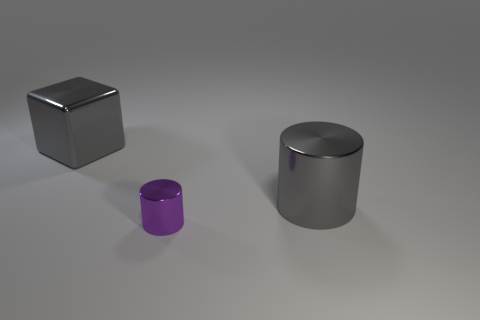What color is the object that is right of the metal cube and behind the tiny purple metallic cylinder?
Offer a very short reply. Gray. Is the shape of the large shiny object on the right side of the gray block the same as the thing that is in front of the big metallic cylinder?
Give a very brief answer. Yes. What is the size of the cylinder that is the same color as the big metal cube?
Offer a terse response. Large. What number of objects are either metallic things that are on the right side of the gray cube or gray metal cylinders?
Provide a short and direct response. 2. Are there an equal number of metallic objects in front of the large shiny cylinder and metallic blocks?
Offer a very short reply. Yes. Does the purple metal cylinder have the same size as the shiny block?
Keep it short and to the point. No. There is a metal object that is the same size as the gray metallic cylinder; what is its color?
Keep it short and to the point. Gray. Do the cube and the gray object on the right side of the small cylinder have the same size?
Your answer should be compact. Yes. What number of large cylinders have the same color as the big cube?
Provide a succinct answer. 1. How many objects are cubes or gray objects that are in front of the gray metallic block?
Offer a very short reply. 2. 